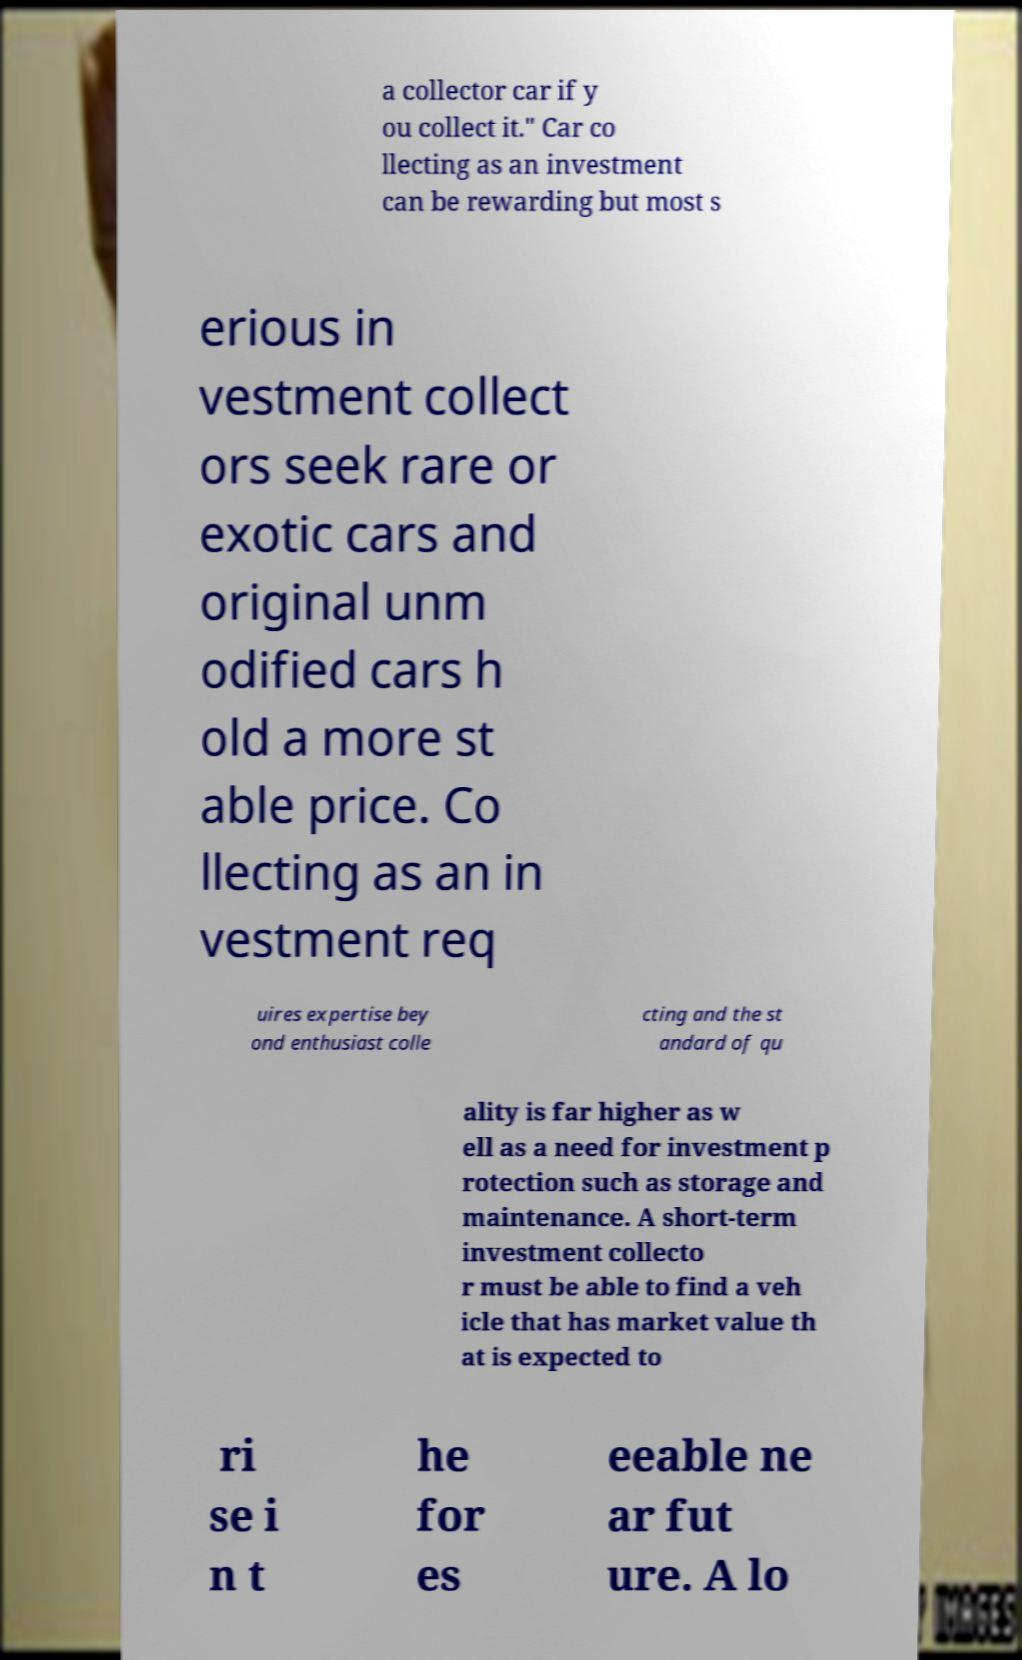Can you accurately transcribe the text from the provided image for me? a collector car if y ou collect it." Car co llecting as an investment can be rewarding but most s erious in vestment collect ors seek rare or exotic cars and original unm odified cars h old a more st able price. Co llecting as an in vestment req uires expertise bey ond enthusiast colle cting and the st andard of qu ality is far higher as w ell as a need for investment p rotection such as storage and maintenance. A short-term investment collecto r must be able to find a veh icle that has market value th at is expected to ri se i n t he for es eeable ne ar fut ure. A lo 